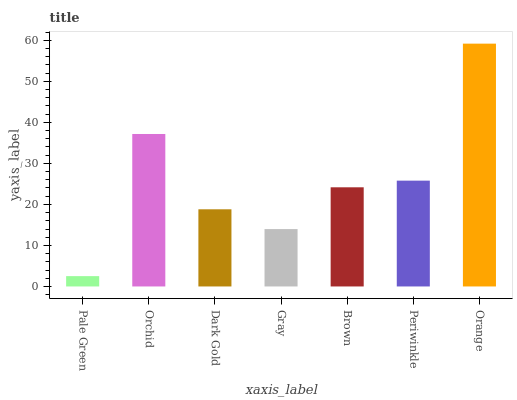Is Pale Green the minimum?
Answer yes or no. Yes. Is Orange the maximum?
Answer yes or no. Yes. Is Orchid the minimum?
Answer yes or no. No. Is Orchid the maximum?
Answer yes or no. No. Is Orchid greater than Pale Green?
Answer yes or no. Yes. Is Pale Green less than Orchid?
Answer yes or no. Yes. Is Pale Green greater than Orchid?
Answer yes or no. No. Is Orchid less than Pale Green?
Answer yes or no. No. Is Brown the high median?
Answer yes or no. Yes. Is Brown the low median?
Answer yes or no. Yes. Is Orchid the high median?
Answer yes or no. No. Is Pale Green the low median?
Answer yes or no. No. 